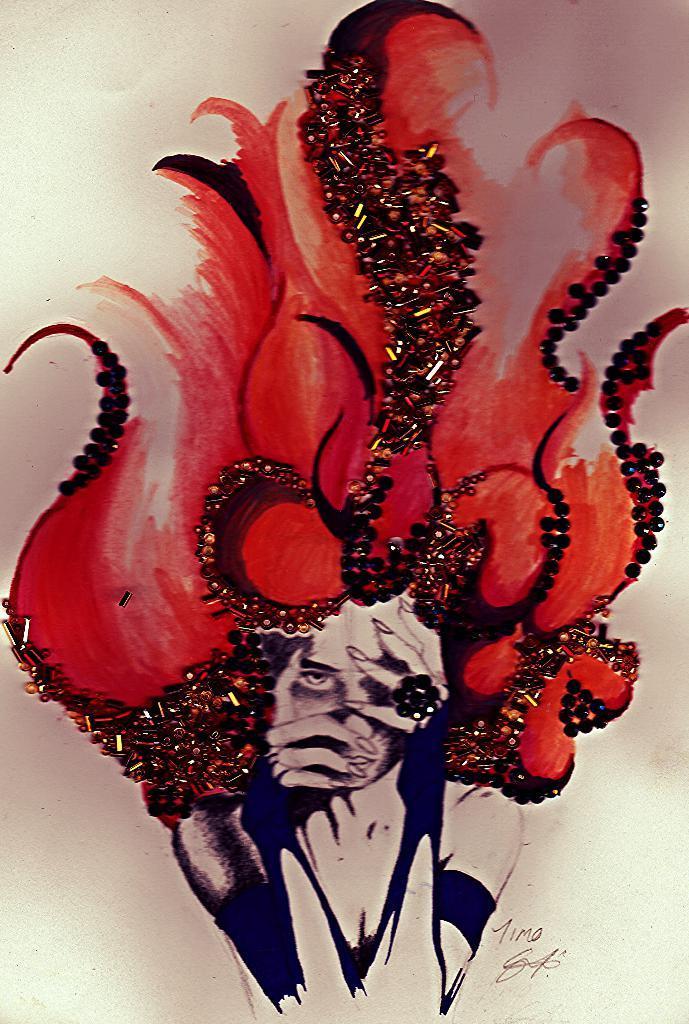Can you describe this image briefly? In this picture there is a painting of a woman and there are objects on the painting. At the bottom it looks like a paper. At the bottom right there is a signature and there is text. 